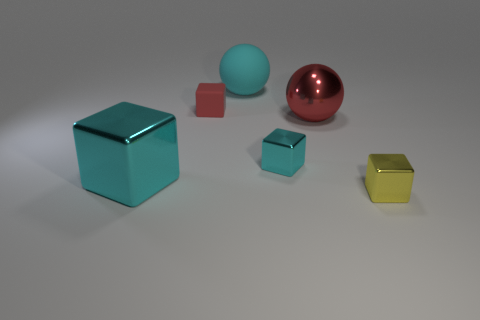What is the material of the ball that is the same color as the small matte thing?
Your answer should be very brief. Metal. There is a sphere that is right of the cyan metallic thing to the right of the big cyan rubber thing; are there any tiny blocks that are to the left of it?
Offer a terse response. Yes. What number of other objects are there of the same color as the big rubber ball?
Provide a succinct answer. 2. There is a red thing right of the tiny red rubber thing; does it have the same size as the red block left of the big matte sphere?
Your answer should be compact. No. Are there an equal number of big cyan matte objects in front of the cyan matte object and large metal objects left of the yellow object?
Your response must be concise. No. Is there any other thing that has the same material as the big red sphere?
Give a very brief answer. Yes. Do the red shiny sphere and the cube behind the large red sphere have the same size?
Give a very brief answer. No. What is the material of the big cyan thing that is to the right of the cyan thing on the left side of the big cyan ball?
Give a very brief answer. Rubber. Are there an equal number of tiny red rubber things behind the red ball and shiny cubes?
Provide a short and direct response. No. There is a thing that is on the left side of the tiny cyan cube and in front of the tiny red matte cube; what is its size?
Your answer should be very brief. Large. 